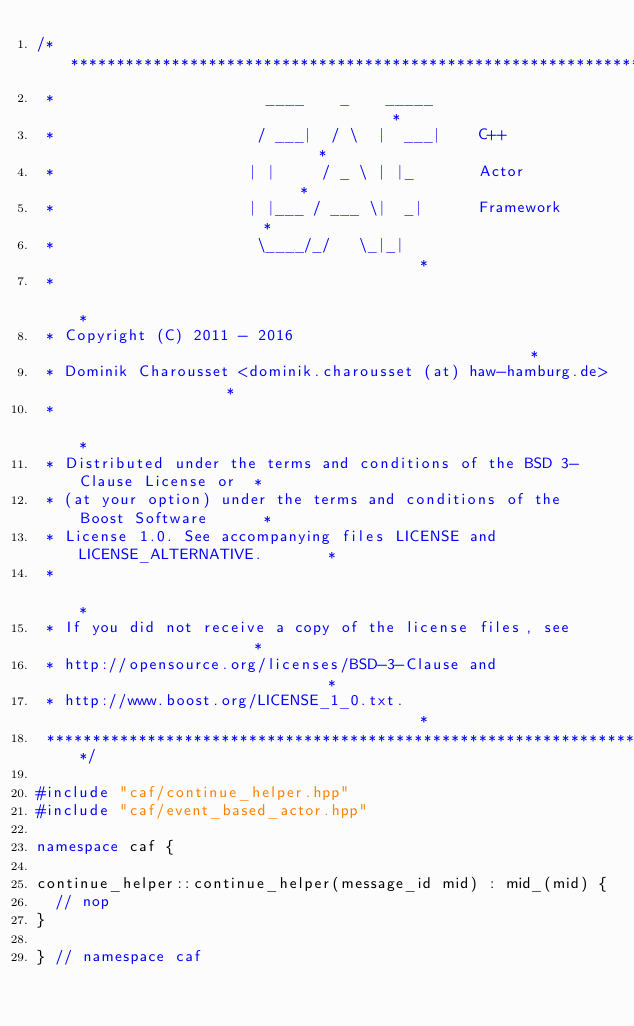Convert code to text. <code><loc_0><loc_0><loc_500><loc_500><_C++_>/******************************************************************************
 *                       ____    _    _____                                   *
 *                      / ___|  / \  |  ___|    C++                           *
 *                     | |     / _ \ | |_       Actor                         *
 *                     | |___ / ___ \|  _|      Framework                     *
 *                      \____/_/   \_|_|                                      *
 *                                                                            *
 * Copyright (C) 2011 - 2016                                                  *
 * Dominik Charousset <dominik.charousset (at) haw-hamburg.de>                *
 *                                                                            *
 * Distributed under the terms and conditions of the BSD 3-Clause License or  *
 * (at your option) under the terms and conditions of the Boost Software      *
 * License 1.0. See accompanying files LICENSE and LICENSE_ALTERNATIVE.       *
 *                                                                            *
 * If you did not receive a copy of the license files, see                    *
 * http://opensource.org/licenses/BSD-3-Clause and                            *
 * http://www.boost.org/LICENSE_1_0.txt.                                      *
 ******************************************************************************/

#include "caf/continue_helper.hpp"
#include "caf/event_based_actor.hpp"

namespace caf {

continue_helper::continue_helper(message_id mid) : mid_(mid) {
  // nop
}

} // namespace caf
</code> 